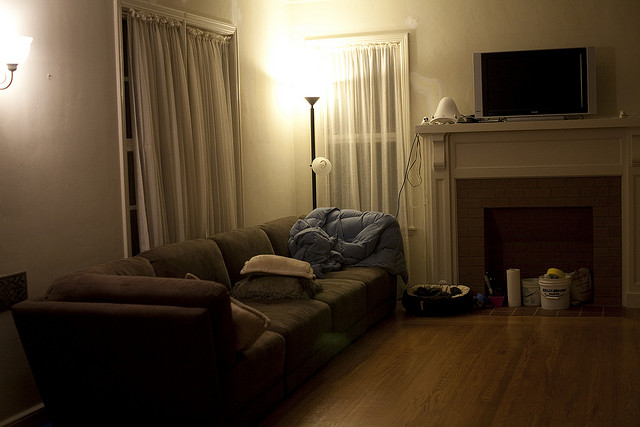<image>What room is the mirror in? It is ambiguous which room the mirror is in. It could possibly be in the living room or the bathroom. What room is the mirror in? I am not sure which room the mirror is in. It can be seen in the living room, bathroom, or dining room. 